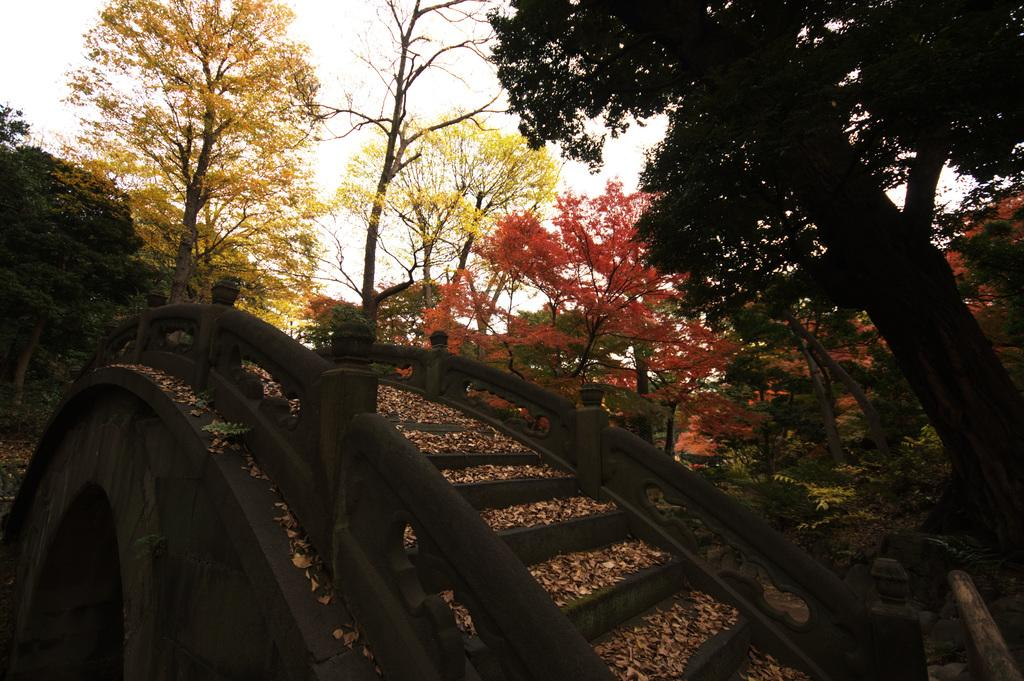What object is located at the front of the image? There is a wooden cart in the front of the image. What can be seen on the ground in the center of the image? Dry leaves are present on the ground in the center of the image. What is visible in the background of the image? There are trees in the background of the image. What type of scarf is draped over the wooden cart in the image? There is no scarf present in the image; it only features a wooden cart, dry leaves, and trees in the background. 